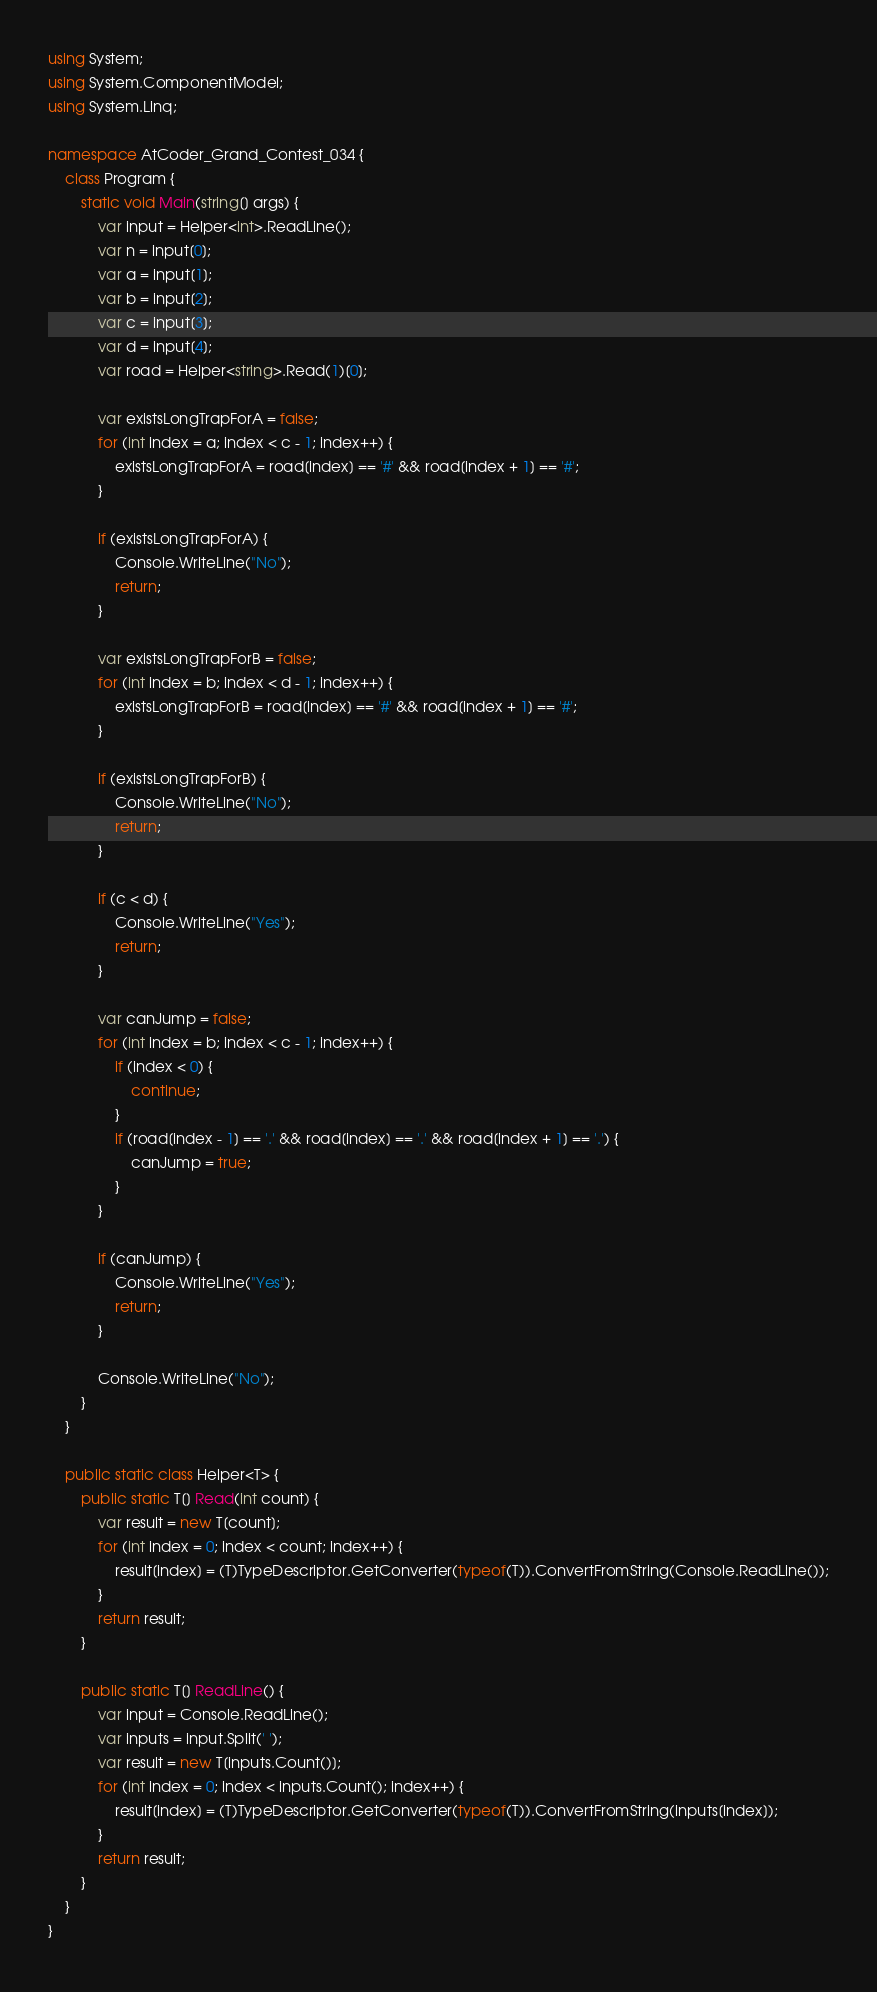Convert code to text. <code><loc_0><loc_0><loc_500><loc_500><_C#_>using System;
using System.ComponentModel;
using System.Linq;

namespace AtCoder_Grand_Contest_034 {
	class Program {
		static void Main(string[] args) {
			var input = Helper<int>.ReadLine();
			var n = input[0];
			var a = input[1];
			var b = input[2];
			var c = input[3];
			var d = input[4];
			var road = Helper<string>.Read(1)[0];

			var existsLongTrapForA = false;
			for (int index = a; index < c - 1; index++) {
				existsLongTrapForA = road[index] == '#' && road[index + 1] == '#';
			}

			if (existsLongTrapForA) {
				Console.WriteLine("No");
				return;
			}

			var existsLongTrapForB = false;
			for (int index = b; index < d - 1; index++) {
				existsLongTrapForB = road[index] == '#' && road[index + 1] == '#';
			}

			if (existsLongTrapForB) {
				Console.WriteLine("No");
				return;
			}

			if (c < d) {
				Console.WriteLine("Yes");
				return;
			}

			var canJump = false;
			for (int index = b; index < c - 1; index++) {
				if (index < 0) {
					continue;
				}
				if (road[index - 1] == '.' && road[index] == '.' && road[index + 1] == '.') {
					canJump = true;
				}
			}

			if (canJump) {
				Console.WriteLine("Yes");
				return;
			}

			Console.WriteLine("No");
		}
	}

	public static class Helper<T> {
		public static T[] Read(int count) {
			var result = new T[count];
			for (int index = 0; index < count; index++) {
				result[index] = (T)TypeDescriptor.GetConverter(typeof(T)).ConvertFromString(Console.ReadLine());
			}
			return result;
		}

		public static T[] ReadLine() {
			var input = Console.ReadLine();
			var inputs = input.Split(' ');
			var result = new T[inputs.Count()];
			for (int index = 0; index < inputs.Count(); index++) {
				result[index] = (T)TypeDescriptor.GetConverter(typeof(T)).ConvertFromString(inputs[index]);
			}
			return result;
		}
	}
}
</code> 